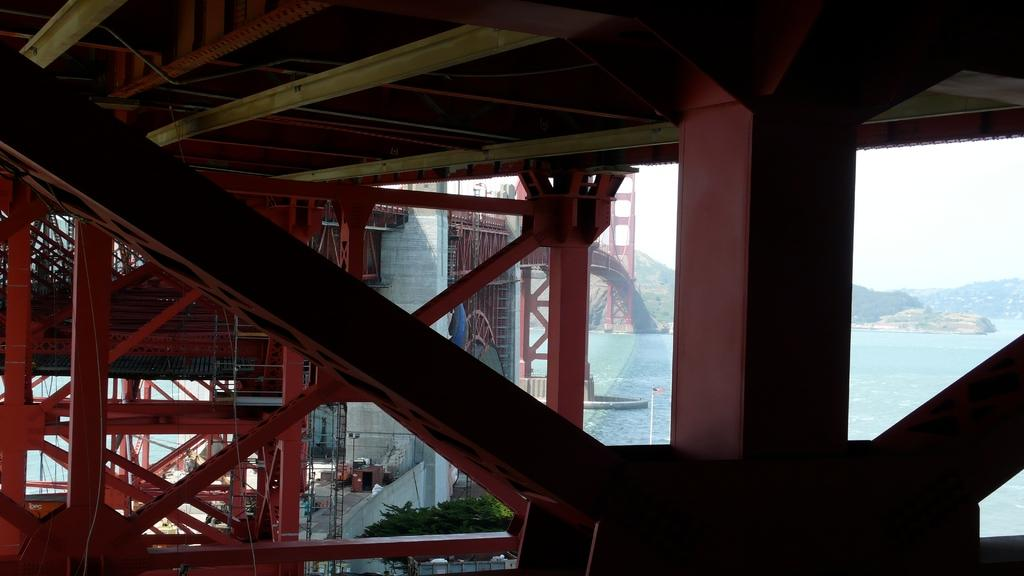What type of structure can be seen in the image? There is a bridge in the image. What color are the poles in the image? The poles in the image are maroon in color. What natural elements can be seen in the image? There are trees, water, and mountains visible in the image. What is on the floor in the image? There are objects on the floor in the image. What color is the sky in the image? The sky is in white color in the image. How many boats are visible in the image? There are no boats visible in the image. What type of crowd can be seen gathering around the bridge in the image? There is no crowd present in the image; it only shows the bridge, poles, trees, water, mountains, and objects on the floor. 